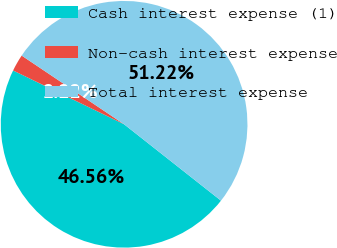Convert chart. <chart><loc_0><loc_0><loc_500><loc_500><pie_chart><fcel>Cash interest expense (1)<fcel>Non-cash interest expense<fcel>Total interest expense<nl><fcel>46.56%<fcel>2.22%<fcel>51.22%<nl></chart> 